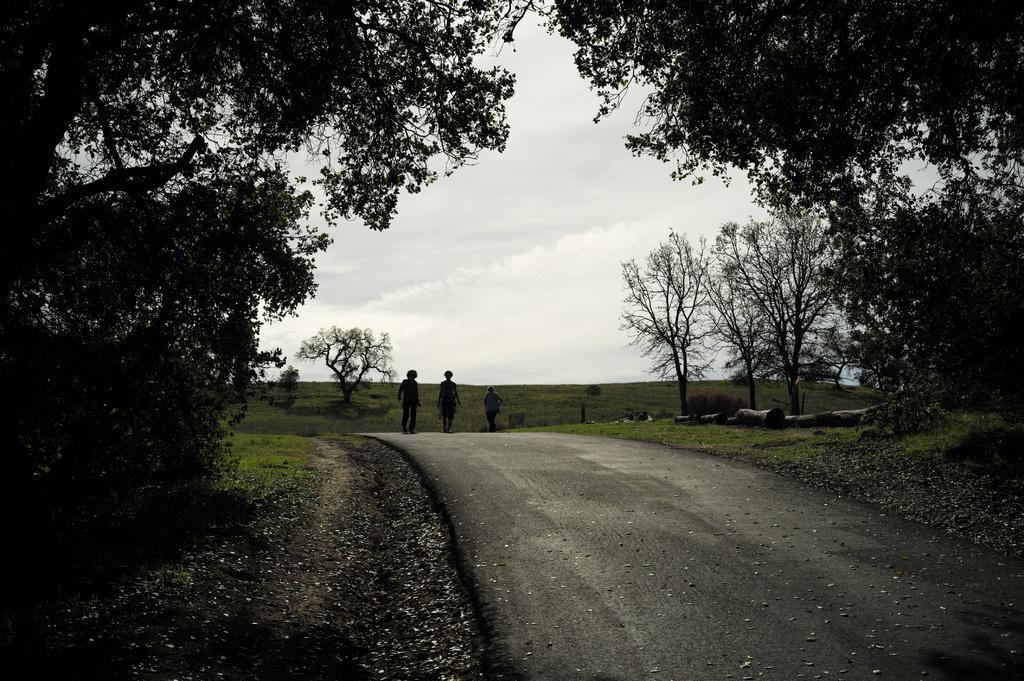Can you describe this image briefly? In the center of the image there are people walking on the road. There are trees to the both sides of the image. In the background of the image there is grass,sky. 